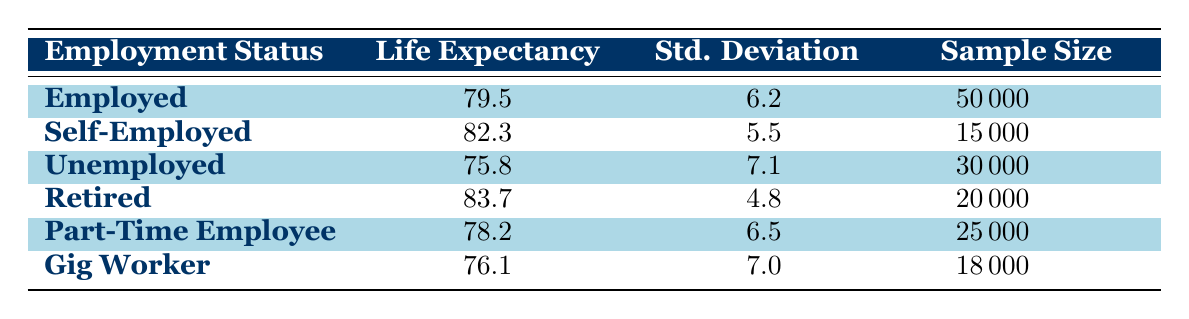What is the average life expectancy for retired individuals? According to the table, the life expectancy for retired individuals is directly listed as 83.7 years.
Answer: 83.7 How many individuals are in the self-employed sample? The sample size for self-employed individuals is specified in the table as 15,000.
Answer: 15,000 What is the difference in life expectancy between unemployed individuals and part-time employees? The life expectancy for unemployed individuals is 75.8 years, and for part-time employees it is 78.2 years. The difference is calculated as 78.2 - 75.8 = 2.4 years.
Answer: 2.4 Is the life expectancy of gig workers greater than that of part-time employees? According to the table, gig workers have a life expectancy of 76.1 years, while part-time employees have a life expectancy of 78.2 years. Since 76.1 is less than 78.2, this statement is false.
Answer: No What is the average life expectancy of employed and self-employed individuals combined? The average life expectancy for employed individuals is 79.5 years and for self-employed individuals it is 82.3 years. To find the combined average, we sum the two averages and divide by 2: (79.5 + 82.3) / 2 = 80.9 years.
Answer: 80.9 How many employed individuals were included in the data? The table lists the sample size for employed individuals as 50,000.
Answer: 50,000 Which employment status has the highest life expectancy? The table indicates that retired individuals have the highest life expectancy at 83.7 years, which is greater than all other statuses listed.
Answer: Retired What is the average life expectancy of unemployed and gig workers? The life expectancy for unemployed individuals is 75.8 years, and for gig workers, it is 76.1 years. The average is (75.8 + 76.1) / 2 = 75.95 years.
Answer: 75.95 Are standard deviations higher for self-employed individuals than for employed individuals? The standard deviation for self-employed individuals is 5.5, while for employed individuals, it is 6.2. Since 5.5 is less than 6.2, this statement is false.
Answer: No 